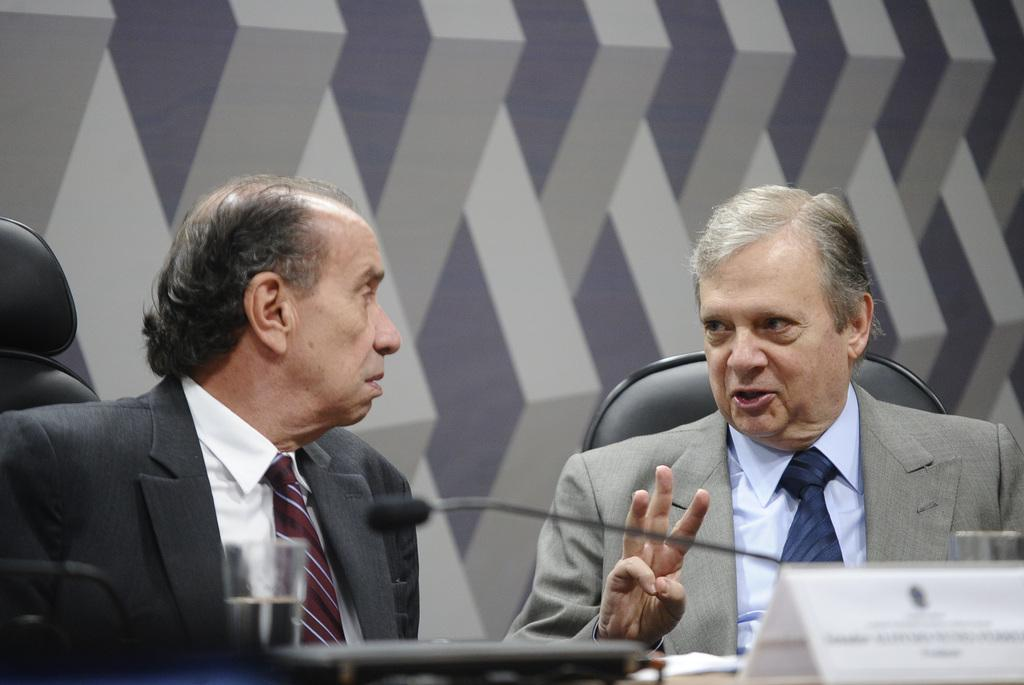How many people are sitting in the image? There are two persons sitting on chairs in the image. What is in front of the persons? There is a mic, a name board, glasses, and other unspecified things in front of the persons. What can be seen in the background of the image? There is a wall in the background. What is the weather like in the image? The provided facts do not mention any information about the weather, so it cannot be determined from the image. Are the persons coughing in the image? There is no indication in the image that the persons are coughing, so it cannot be determined from the image. 